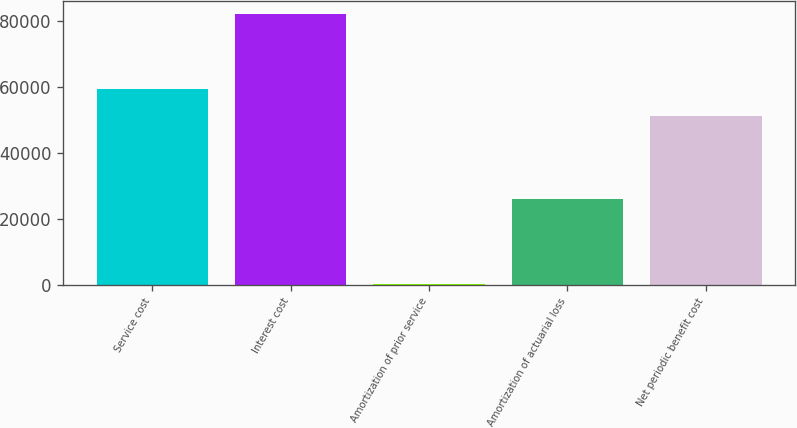Convert chart. <chart><loc_0><loc_0><loc_500><loc_500><bar_chart><fcel>Service cost<fcel>Interest cost<fcel>Amortization of prior service<fcel>Amortization of actuarial loss<fcel>Net periodic benefit cost<nl><fcel>59338.1<fcel>82029<fcel>338<fcel>25909<fcel>51169<nl></chart> 